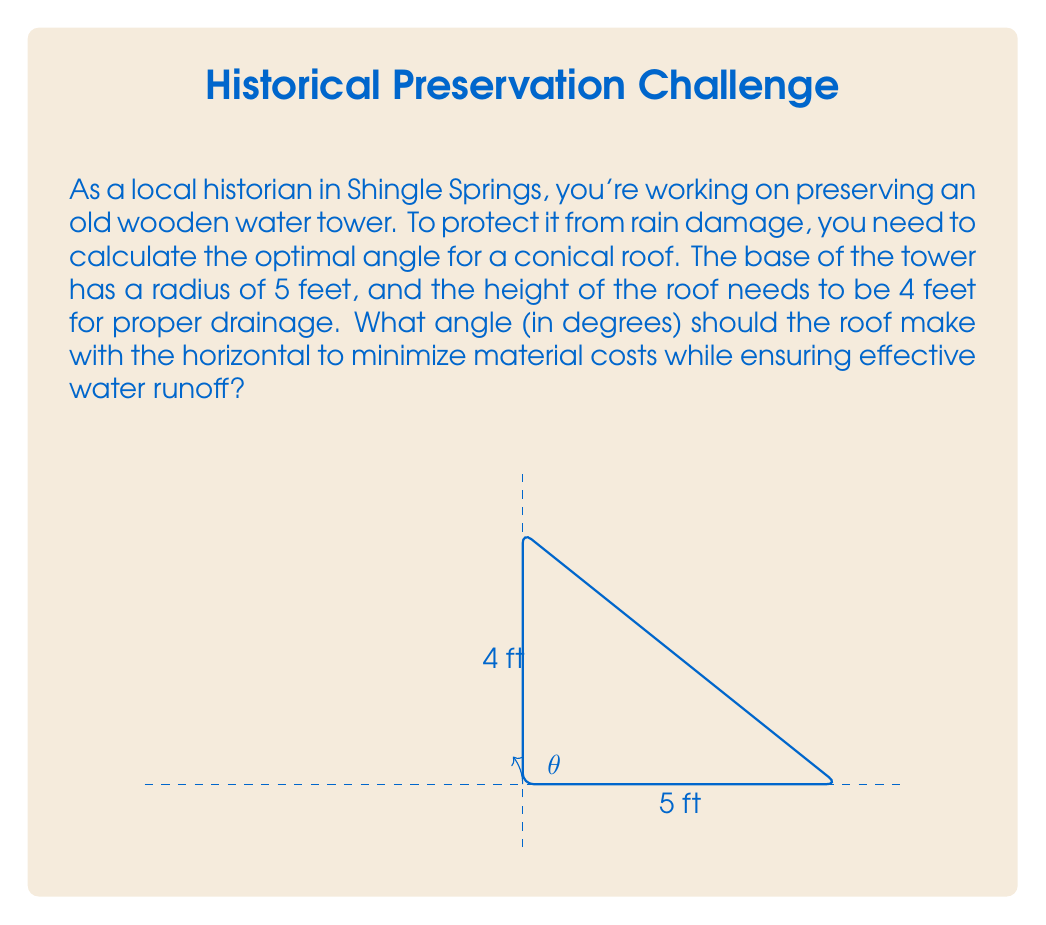What is the answer to this math problem? Let's approach this step-by-step:

1) In this scenario, we have a right-angled triangle. The base radius forms one side (adjacent to our angle), and the height forms the other (opposite to our angle).

2) We can use the tangent function to find the angle. The tangent of an angle is the ratio of the opposite side to the adjacent side.

3) Let θ be the angle we're looking for. Then:

   $$\tan(\theta) = \frac{\text{opposite}}{\text{adjacent}} = \frac{\text{height}}{\text{radius}} = \frac{4}{5}$$

4) To find θ, we need to use the inverse tangent (arctan or tan^(-1)) function:

   $$\theta = \arctan(\frac{4}{5})$$

5) Using a calculator or computer, we can evaluate this:

   $$\theta \approx 0.6747 \text{ radians}$$

6) However, we need the answer in degrees. To convert from radians to degrees, we multiply by (180/π):

   $$\theta \approx 0.6747 \times \frac{180}{\pi} \approx 38.66°$$

7) Rounding to the nearest degree (which is practical for construction purposes):

   $$\theta \approx 39°$$

This angle provides a good balance between effective water runoff and minimizing material costs for the conical roof.
Answer: 39° 